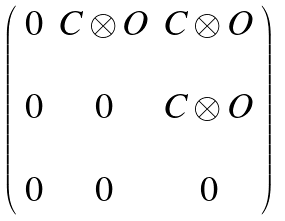<formula> <loc_0><loc_0><loc_500><loc_500>\left ( \begin{array} { c c c } 0 & { C } \otimes { O } & { C } \otimes { O } \\ & & \\ 0 & 0 & { C } \otimes { O } \\ & & \\ 0 & 0 & 0 \end{array} \right )</formula> 